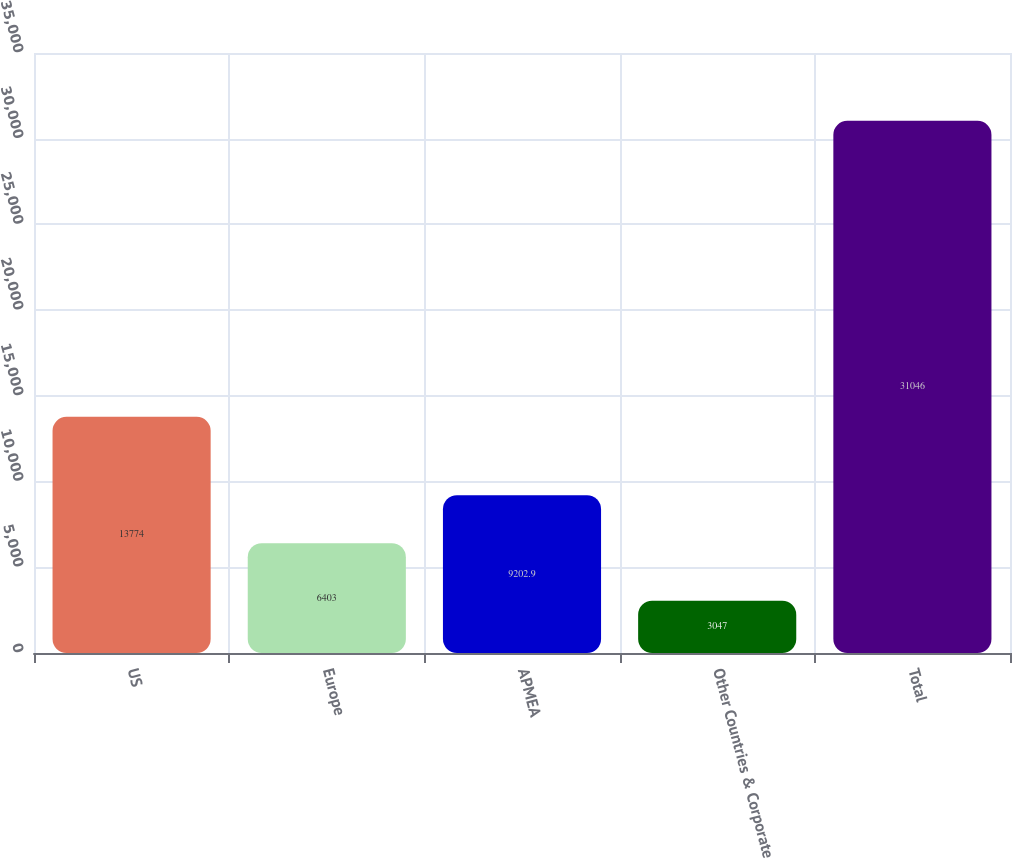Convert chart. <chart><loc_0><loc_0><loc_500><loc_500><bar_chart><fcel>US<fcel>Europe<fcel>APMEA<fcel>Other Countries & Corporate<fcel>Total<nl><fcel>13774<fcel>6403<fcel>9202.9<fcel>3047<fcel>31046<nl></chart> 